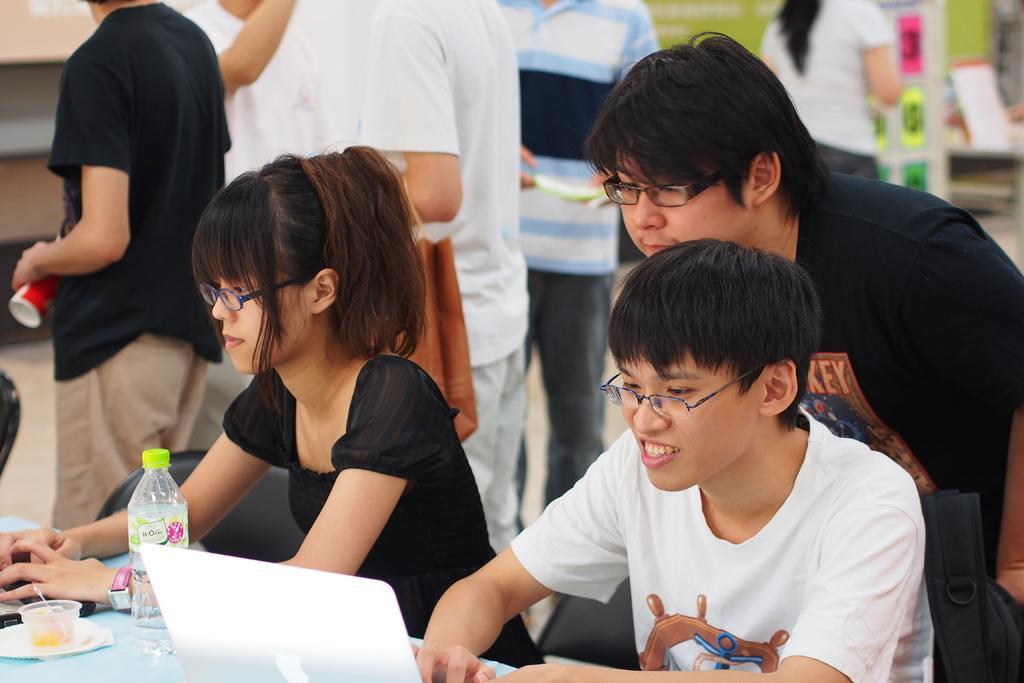Please provide a concise description of this image. In this picture we can see two persons are sitting on the chairs. There is a table. On the table we can see a laptop, bottle, and a cup. In the background we can see few people. 